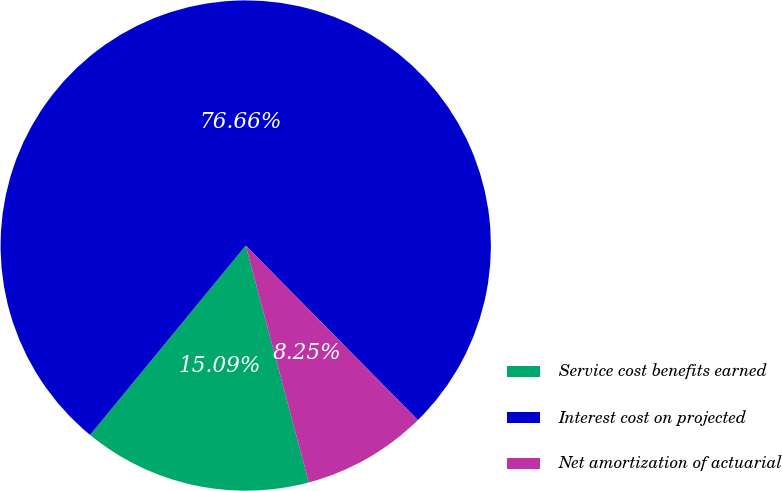<chart> <loc_0><loc_0><loc_500><loc_500><pie_chart><fcel>Service cost benefits earned<fcel>Interest cost on projected<fcel>Net amortization of actuarial<nl><fcel>15.09%<fcel>76.66%<fcel>8.25%<nl></chart> 